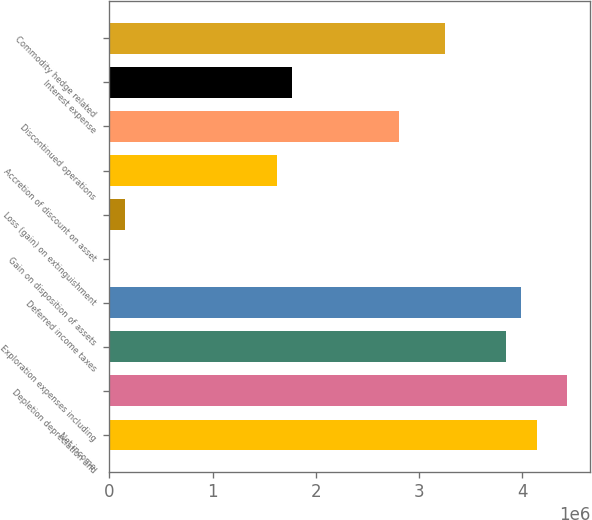Convert chart. <chart><loc_0><loc_0><loc_500><loc_500><bar_chart><fcel>Net income<fcel>Depletion depreciation and<fcel>Exploration expenses including<fcel>Deferred income taxes<fcel>Gain on disposition of assets<fcel>Loss (gain) on extinguishment<fcel>Accretion of discount on asset<fcel>Discontinued operations<fcel>Interest expense<fcel>Commodity hedge related<nl><fcel>4.13982e+06<fcel>4.43552e+06<fcel>3.84412e+06<fcel>3.99197e+06<fcel>39<fcel>147888<fcel>1.62638e+06<fcel>2.80918e+06<fcel>1.77423e+06<fcel>3.25273e+06<nl></chart> 